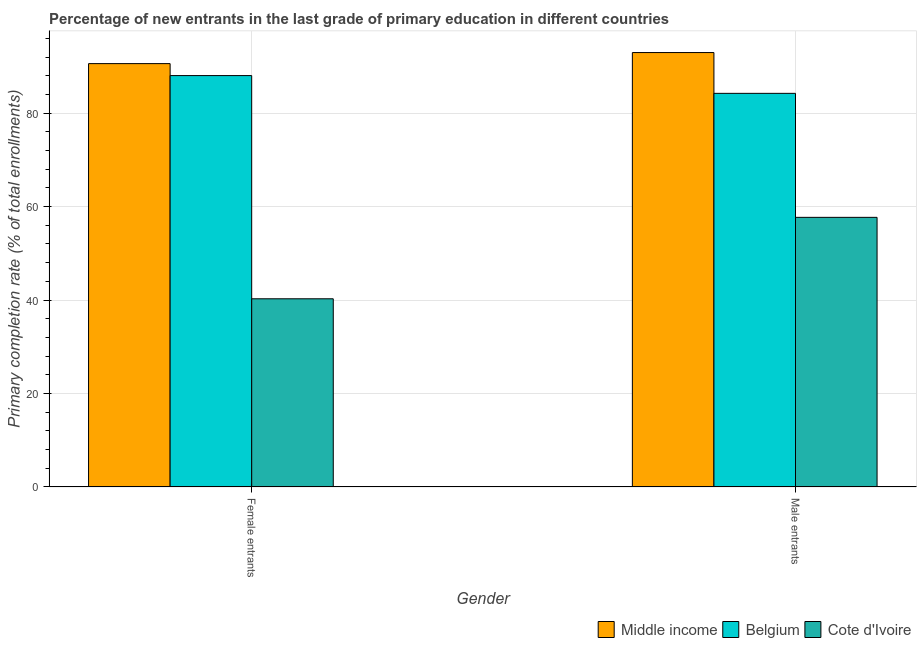How many different coloured bars are there?
Offer a terse response. 3. Are the number of bars per tick equal to the number of legend labels?
Your answer should be very brief. Yes. Are the number of bars on each tick of the X-axis equal?
Your answer should be very brief. Yes. How many bars are there on the 1st tick from the left?
Provide a succinct answer. 3. How many bars are there on the 1st tick from the right?
Provide a short and direct response. 3. What is the label of the 1st group of bars from the left?
Offer a terse response. Female entrants. What is the primary completion rate of male entrants in Middle income?
Your response must be concise. 92.96. Across all countries, what is the maximum primary completion rate of female entrants?
Your response must be concise. 90.59. Across all countries, what is the minimum primary completion rate of male entrants?
Give a very brief answer. 57.7. In which country was the primary completion rate of male entrants maximum?
Provide a succinct answer. Middle income. In which country was the primary completion rate of male entrants minimum?
Your answer should be compact. Cote d'Ivoire. What is the total primary completion rate of male entrants in the graph?
Make the answer very short. 234.89. What is the difference between the primary completion rate of female entrants in Middle income and that in Cote d'Ivoire?
Your answer should be compact. 50.32. What is the difference between the primary completion rate of female entrants in Belgium and the primary completion rate of male entrants in Middle income?
Keep it short and to the point. -4.93. What is the average primary completion rate of male entrants per country?
Offer a very short reply. 78.3. What is the difference between the primary completion rate of male entrants and primary completion rate of female entrants in Belgium?
Your answer should be compact. -3.8. In how many countries, is the primary completion rate of female entrants greater than 88 %?
Make the answer very short. 2. What is the ratio of the primary completion rate of male entrants in Middle income to that in Cote d'Ivoire?
Your response must be concise. 1.61. In how many countries, is the primary completion rate of male entrants greater than the average primary completion rate of male entrants taken over all countries?
Make the answer very short. 2. What does the 1st bar from the right in Female entrants represents?
Your response must be concise. Cote d'Ivoire. Are all the bars in the graph horizontal?
Your response must be concise. No. How many countries are there in the graph?
Your answer should be compact. 3. Does the graph contain grids?
Offer a very short reply. Yes. How many legend labels are there?
Provide a succinct answer. 3. How are the legend labels stacked?
Ensure brevity in your answer.  Horizontal. What is the title of the graph?
Offer a terse response. Percentage of new entrants in the last grade of primary education in different countries. What is the label or title of the X-axis?
Offer a very short reply. Gender. What is the label or title of the Y-axis?
Offer a very short reply. Primary completion rate (% of total enrollments). What is the Primary completion rate (% of total enrollments) in Middle income in Female entrants?
Keep it short and to the point. 90.59. What is the Primary completion rate (% of total enrollments) in Belgium in Female entrants?
Keep it short and to the point. 88.03. What is the Primary completion rate (% of total enrollments) of Cote d'Ivoire in Female entrants?
Offer a very short reply. 40.27. What is the Primary completion rate (% of total enrollments) in Middle income in Male entrants?
Make the answer very short. 92.96. What is the Primary completion rate (% of total enrollments) in Belgium in Male entrants?
Your response must be concise. 84.23. What is the Primary completion rate (% of total enrollments) in Cote d'Ivoire in Male entrants?
Keep it short and to the point. 57.7. Across all Gender, what is the maximum Primary completion rate (% of total enrollments) of Middle income?
Provide a short and direct response. 92.96. Across all Gender, what is the maximum Primary completion rate (% of total enrollments) in Belgium?
Give a very brief answer. 88.03. Across all Gender, what is the maximum Primary completion rate (% of total enrollments) in Cote d'Ivoire?
Give a very brief answer. 57.7. Across all Gender, what is the minimum Primary completion rate (% of total enrollments) in Middle income?
Offer a very short reply. 90.59. Across all Gender, what is the minimum Primary completion rate (% of total enrollments) in Belgium?
Your response must be concise. 84.23. Across all Gender, what is the minimum Primary completion rate (% of total enrollments) in Cote d'Ivoire?
Give a very brief answer. 40.27. What is the total Primary completion rate (% of total enrollments) of Middle income in the graph?
Your response must be concise. 183.56. What is the total Primary completion rate (% of total enrollments) in Belgium in the graph?
Ensure brevity in your answer.  172.26. What is the total Primary completion rate (% of total enrollments) in Cote d'Ivoire in the graph?
Your answer should be compact. 97.97. What is the difference between the Primary completion rate (% of total enrollments) in Middle income in Female entrants and that in Male entrants?
Give a very brief answer. -2.37. What is the difference between the Primary completion rate (% of total enrollments) of Belgium in Female entrants and that in Male entrants?
Your answer should be compact. 3.8. What is the difference between the Primary completion rate (% of total enrollments) in Cote d'Ivoire in Female entrants and that in Male entrants?
Ensure brevity in your answer.  -17.43. What is the difference between the Primary completion rate (% of total enrollments) in Middle income in Female entrants and the Primary completion rate (% of total enrollments) in Belgium in Male entrants?
Ensure brevity in your answer.  6.36. What is the difference between the Primary completion rate (% of total enrollments) of Middle income in Female entrants and the Primary completion rate (% of total enrollments) of Cote d'Ivoire in Male entrants?
Your answer should be very brief. 32.89. What is the difference between the Primary completion rate (% of total enrollments) of Belgium in Female entrants and the Primary completion rate (% of total enrollments) of Cote d'Ivoire in Male entrants?
Your answer should be very brief. 30.33. What is the average Primary completion rate (% of total enrollments) in Middle income per Gender?
Your answer should be very brief. 91.78. What is the average Primary completion rate (% of total enrollments) of Belgium per Gender?
Provide a succinct answer. 86.13. What is the average Primary completion rate (% of total enrollments) in Cote d'Ivoire per Gender?
Offer a very short reply. 48.99. What is the difference between the Primary completion rate (% of total enrollments) of Middle income and Primary completion rate (% of total enrollments) of Belgium in Female entrants?
Provide a short and direct response. 2.56. What is the difference between the Primary completion rate (% of total enrollments) in Middle income and Primary completion rate (% of total enrollments) in Cote d'Ivoire in Female entrants?
Keep it short and to the point. 50.32. What is the difference between the Primary completion rate (% of total enrollments) of Belgium and Primary completion rate (% of total enrollments) of Cote d'Ivoire in Female entrants?
Keep it short and to the point. 47.76. What is the difference between the Primary completion rate (% of total enrollments) in Middle income and Primary completion rate (% of total enrollments) in Belgium in Male entrants?
Your answer should be compact. 8.73. What is the difference between the Primary completion rate (% of total enrollments) in Middle income and Primary completion rate (% of total enrollments) in Cote d'Ivoire in Male entrants?
Provide a short and direct response. 35.26. What is the difference between the Primary completion rate (% of total enrollments) in Belgium and Primary completion rate (% of total enrollments) in Cote d'Ivoire in Male entrants?
Offer a very short reply. 26.53. What is the ratio of the Primary completion rate (% of total enrollments) in Middle income in Female entrants to that in Male entrants?
Keep it short and to the point. 0.97. What is the ratio of the Primary completion rate (% of total enrollments) of Belgium in Female entrants to that in Male entrants?
Offer a terse response. 1.05. What is the ratio of the Primary completion rate (% of total enrollments) of Cote d'Ivoire in Female entrants to that in Male entrants?
Provide a succinct answer. 0.7. What is the difference between the highest and the second highest Primary completion rate (% of total enrollments) of Middle income?
Ensure brevity in your answer.  2.37. What is the difference between the highest and the second highest Primary completion rate (% of total enrollments) of Belgium?
Your answer should be compact. 3.8. What is the difference between the highest and the second highest Primary completion rate (% of total enrollments) of Cote d'Ivoire?
Make the answer very short. 17.43. What is the difference between the highest and the lowest Primary completion rate (% of total enrollments) of Middle income?
Provide a short and direct response. 2.37. What is the difference between the highest and the lowest Primary completion rate (% of total enrollments) of Belgium?
Your answer should be very brief. 3.8. What is the difference between the highest and the lowest Primary completion rate (% of total enrollments) of Cote d'Ivoire?
Your answer should be very brief. 17.43. 